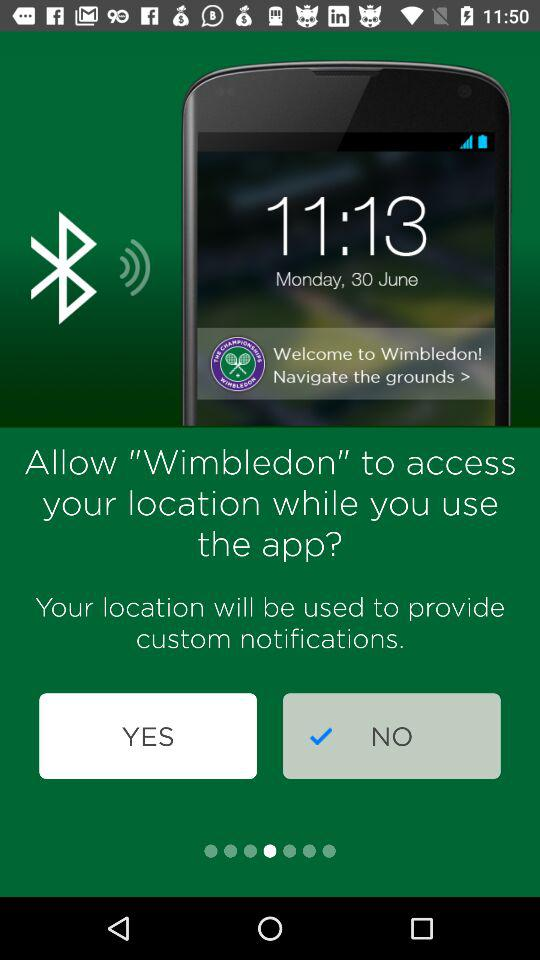What is the day on June 30th? The day is Monday. 